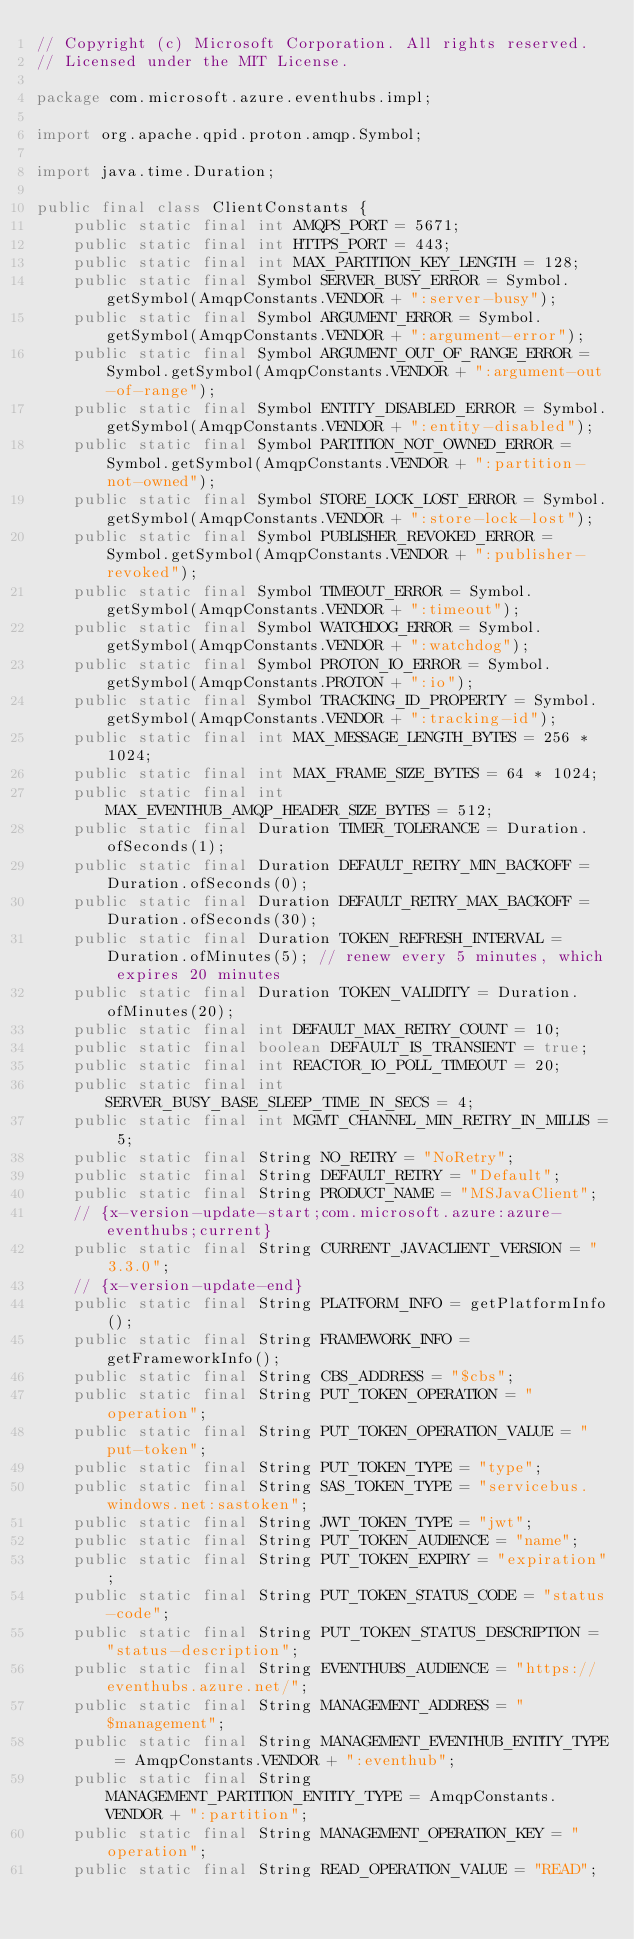Convert code to text. <code><loc_0><loc_0><loc_500><loc_500><_Java_>// Copyright (c) Microsoft Corporation. All rights reserved.
// Licensed under the MIT License.

package com.microsoft.azure.eventhubs.impl;

import org.apache.qpid.proton.amqp.Symbol;

import java.time.Duration;

public final class ClientConstants {
    public static final int AMQPS_PORT = 5671;
    public static final int HTTPS_PORT = 443;
    public static final int MAX_PARTITION_KEY_LENGTH = 128;
    public static final Symbol SERVER_BUSY_ERROR = Symbol.getSymbol(AmqpConstants.VENDOR + ":server-busy");
    public static final Symbol ARGUMENT_ERROR = Symbol.getSymbol(AmqpConstants.VENDOR + ":argument-error");
    public static final Symbol ARGUMENT_OUT_OF_RANGE_ERROR = Symbol.getSymbol(AmqpConstants.VENDOR + ":argument-out-of-range");
    public static final Symbol ENTITY_DISABLED_ERROR = Symbol.getSymbol(AmqpConstants.VENDOR + ":entity-disabled");
    public static final Symbol PARTITION_NOT_OWNED_ERROR = Symbol.getSymbol(AmqpConstants.VENDOR + ":partition-not-owned");
    public static final Symbol STORE_LOCK_LOST_ERROR = Symbol.getSymbol(AmqpConstants.VENDOR + ":store-lock-lost");
    public static final Symbol PUBLISHER_REVOKED_ERROR = Symbol.getSymbol(AmqpConstants.VENDOR + ":publisher-revoked");
    public static final Symbol TIMEOUT_ERROR = Symbol.getSymbol(AmqpConstants.VENDOR + ":timeout");
    public static final Symbol WATCHDOG_ERROR = Symbol.getSymbol(AmqpConstants.VENDOR + ":watchdog");
    public static final Symbol PROTON_IO_ERROR = Symbol.getSymbol(AmqpConstants.PROTON + ":io");
    public static final Symbol TRACKING_ID_PROPERTY = Symbol.getSymbol(AmqpConstants.VENDOR + ":tracking-id");
    public static final int MAX_MESSAGE_LENGTH_BYTES = 256 * 1024;
    public static final int MAX_FRAME_SIZE_BYTES = 64 * 1024;
    public static final int MAX_EVENTHUB_AMQP_HEADER_SIZE_BYTES = 512;
    public static final Duration TIMER_TOLERANCE = Duration.ofSeconds(1);
    public static final Duration DEFAULT_RETRY_MIN_BACKOFF = Duration.ofSeconds(0);
    public static final Duration DEFAULT_RETRY_MAX_BACKOFF = Duration.ofSeconds(30);
    public static final Duration TOKEN_REFRESH_INTERVAL = Duration.ofMinutes(5); // renew every 5 minutes, which expires 20 minutes
    public static final Duration TOKEN_VALIDITY = Duration.ofMinutes(20);
    public static final int DEFAULT_MAX_RETRY_COUNT = 10;
    public static final boolean DEFAULT_IS_TRANSIENT = true;
    public static final int REACTOR_IO_POLL_TIMEOUT = 20;
    public static final int SERVER_BUSY_BASE_SLEEP_TIME_IN_SECS = 4;
    public static final int MGMT_CHANNEL_MIN_RETRY_IN_MILLIS = 5;
    public static final String NO_RETRY = "NoRetry";
    public static final String DEFAULT_RETRY = "Default";
    public static final String PRODUCT_NAME = "MSJavaClient";
    // {x-version-update-start;com.microsoft.azure:azure-eventhubs;current}
    public static final String CURRENT_JAVACLIENT_VERSION = "3.3.0";
    // {x-version-update-end}
    public static final String PLATFORM_INFO = getPlatformInfo();
    public static final String FRAMEWORK_INFO = getFrameworkInfo();
    public static final String CBS_ADDRESS = "$cbs";
    public static final String PUT_TOKEN_OPERATION = "operation";
    public static final String PUT_TOKEN_OPERATION_VALUE = "put-token";
    public static final String PUT_TOKEN_TYPE = "type";
    public static final String SAS_TOKEN_TYPE = "servicebus.windows.net:sastoken";
    public static final String JWT_TOKEN_TYPE = "jwt";
    public static final String PUT_TOKEN_AUDIENCE = "name";
    public static final String PUT_TOKEN_EXPIRY = "expiration";
    public static final String PUT_TOKEN_STATUS_CODE = "status-code";
    public static final String PUT_TOKEN_STATUS_DESCRIPTION = "status-description";
    public static final String EVENTHUBS_AUDIENCE = "https://eventhubs.azure.net/";
    public static final String MANAGEMENT_ADDRESS = "$management";
    public static final String MANAGEMENT_EVENTHUB_ENTITY_TYPE = AmqpConstants.VENDOR + ":eventhub";
    public static final String MANAGEMENT_PARTITION_ENTITY_TYPE = AmqpConstants.VENDOR + ":partition";
    public static final String MANAGEMENT_OPERATION_KEY = "operation";
    public static final String READ_OPERATION_VALUE = "READ";</code> 